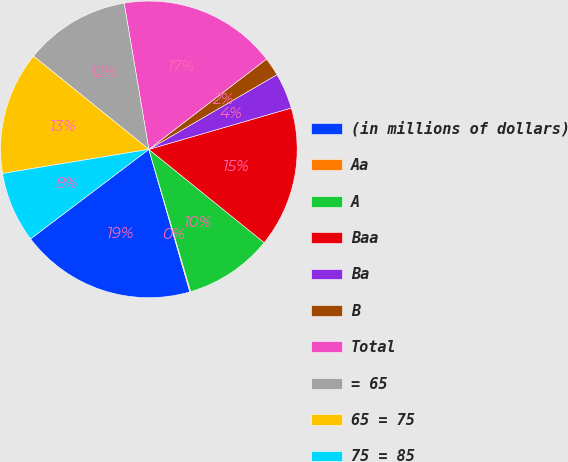<chart> <loc_0><loc_0><loc_500><loc_500><pie_chart><fcel>(in millions of dollars)<fcel>Aa<fcel>A<fcel>Baa<fcel>Ba<fcel>B<fcel>Total<fcel>= 65<fcel>65 = 75<fcel>75 = 85<nl><fcel>19.15%<fcel>0.1%<fcel>9.62%<fcel>15.32%<fcel>3.91%<fcel>2.01%<fcel>17.25%<fcel>11.52%<fcel>13.42%<fcel>7.71%<nl></chart> 